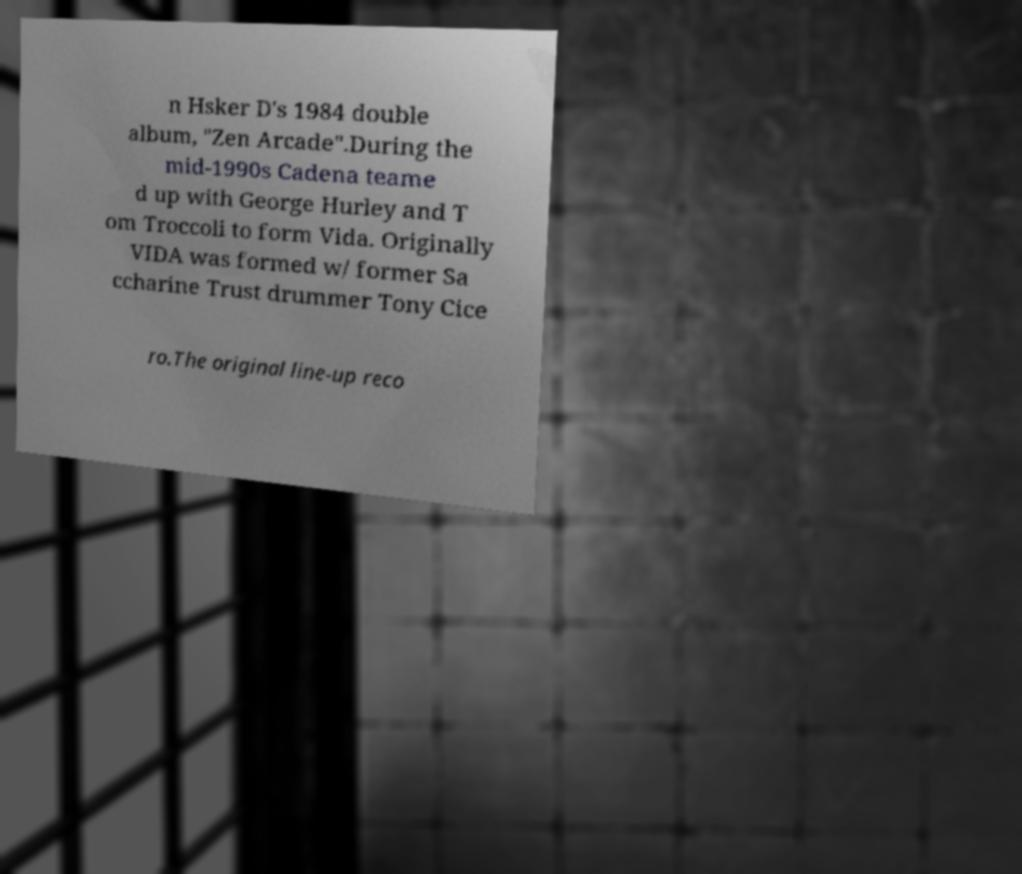Could you extract and type out the text from this image? n Hsker D's 1984 double album, "Zen Arcade".During the mid-1990s Cadena teame d up with George Hurley and T om Troccoli to form Vida. Originally VIDA was formed w/ former Sa ccharine Trust drummer Tony Cice ro.The original line-up reco 